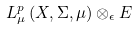Convert formula to latex. <formula><loc_0><loc_0><loc_500><loc_500>L _ { \mu } ^ { p } \left ( X , \Sigma , \mu \right ) \otimes _ { \epsilon } E</formula> 